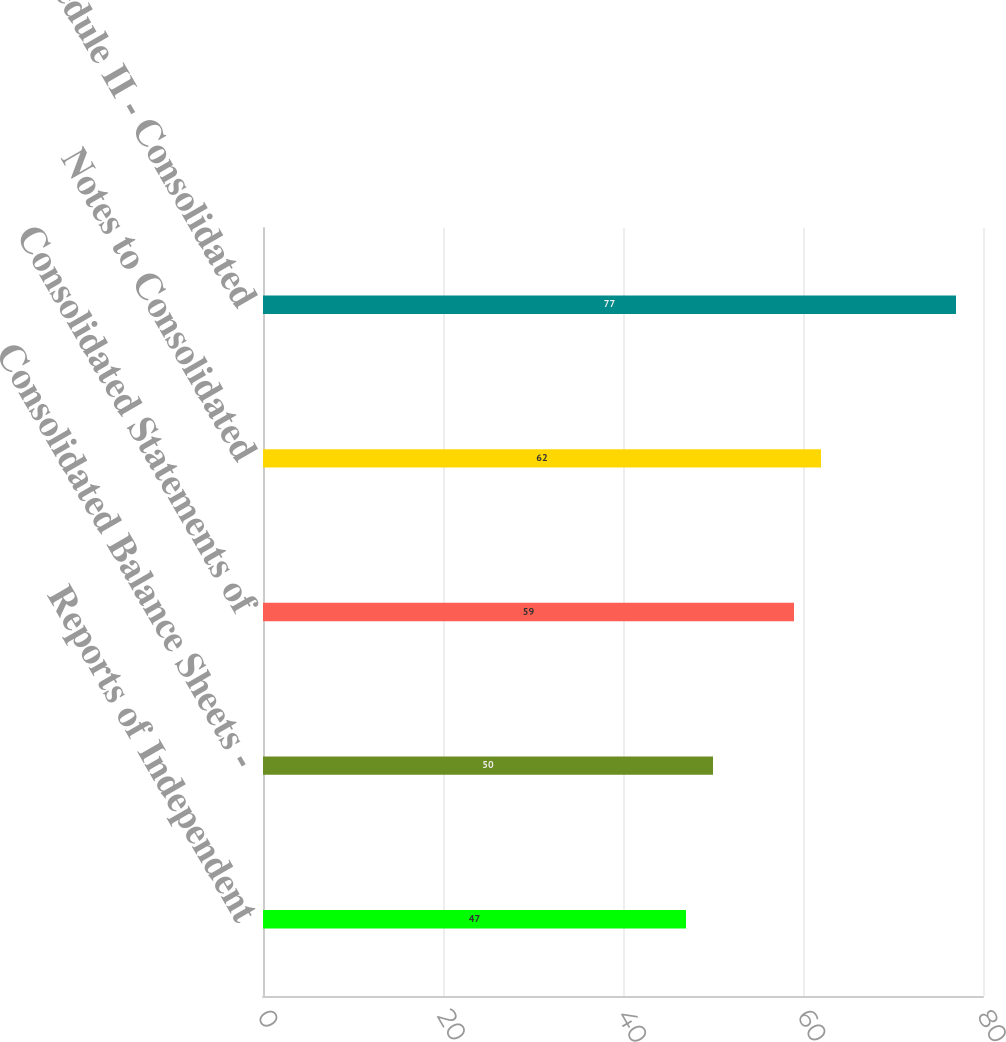<chart> <loc_0><loc_0><loc_500><loc_500><bar_chart><fcel>Reports of Independent<fcel>Consolidated Balance Sheets -<fcel>Consolidated Statements of<fcel>Notes to Consolidated<fcel>Schedule II - Consolidated<nl><fcel>47<fcel>50<fcel>59<fcel>62<fcel>77<nl></chart> 